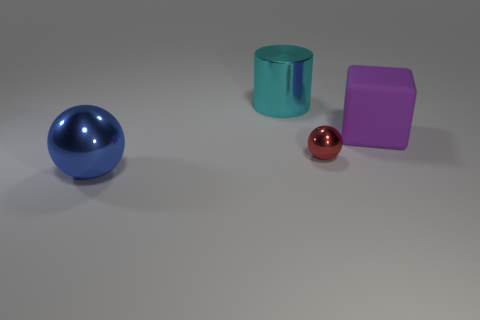Add 1 large yellow metal cylinders. How many objects exist? 5 Subtract all cylinders. How many objects are left? 3 Add 4 large purple rubber things. How many large purple rubber things exist? 5 Subtract 1 blue spheres. How many objects are left? 3 Subtract all blue matte things. Subtract all red shiny objects. How many objects are left? 3 Add 3 big objects. How many big objects are left? 6 